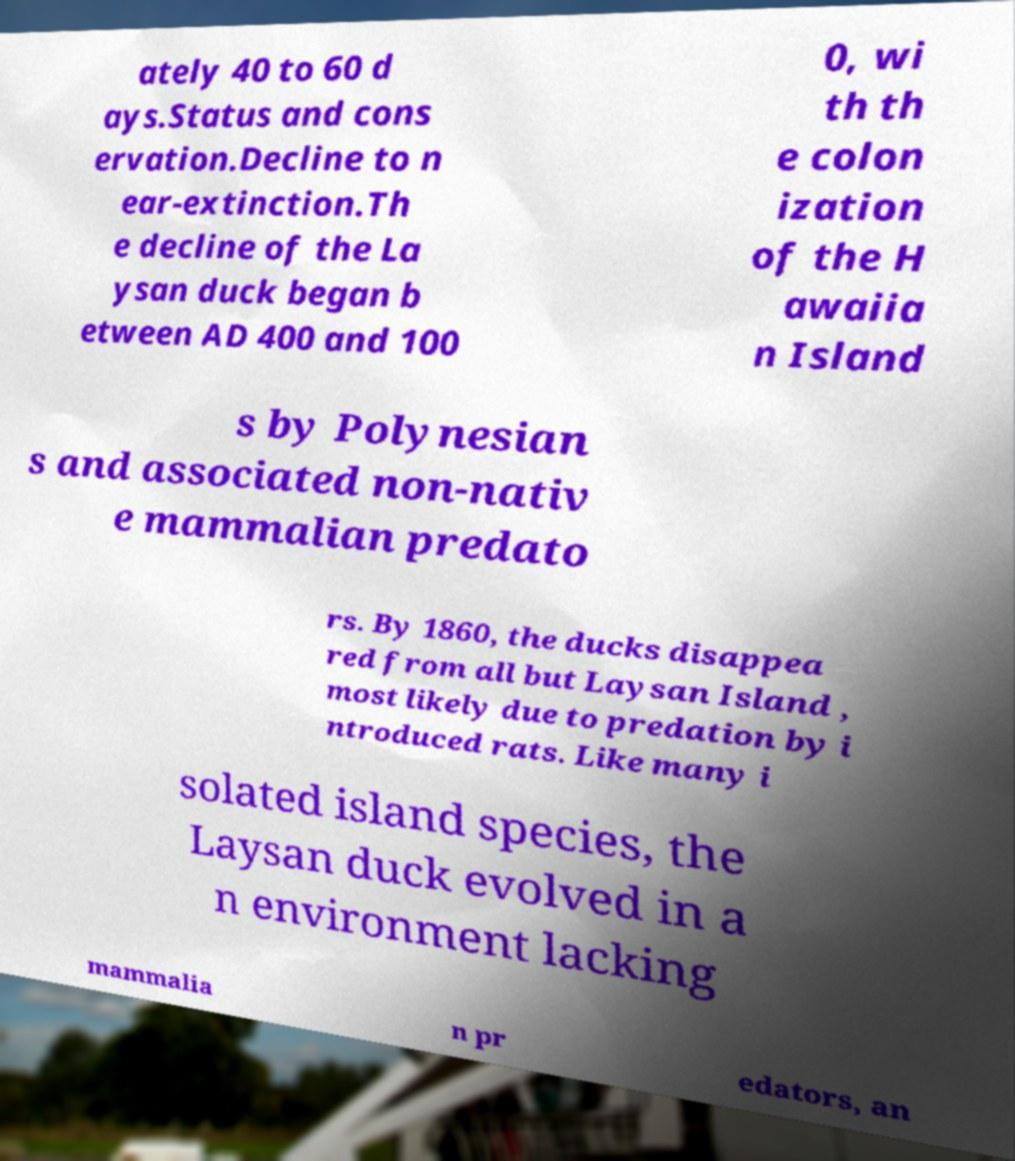There's text embedded in this image that I need extracted. Can you transcribe it verbatim? ately 40 to 60 d ays.Status and cons ervation.Decline to n ear-extinction.Th e decline of the La ysan duck began b etween AD 400 and 100 0, wi th th e colon ization of the H awaiia n Island s by Polynesian s and associated non-nativ e mammalian predato rs. By 1860, the ducks disappea red from all but Laysan Island , most likely due to predation by i ntroduced rats. Like many i solated island species, the Laysan duck evolved in a n environment lacking mammalia n pr edators, an 